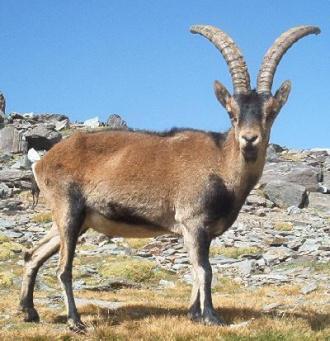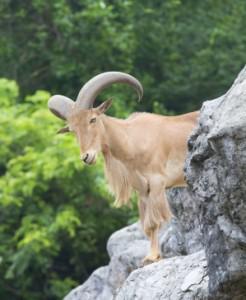The first image is the image on the left, the second image is the image on the right. Given the left and right images, does the statement "There are more than two animals." hold true? Answer yes or no. No. 